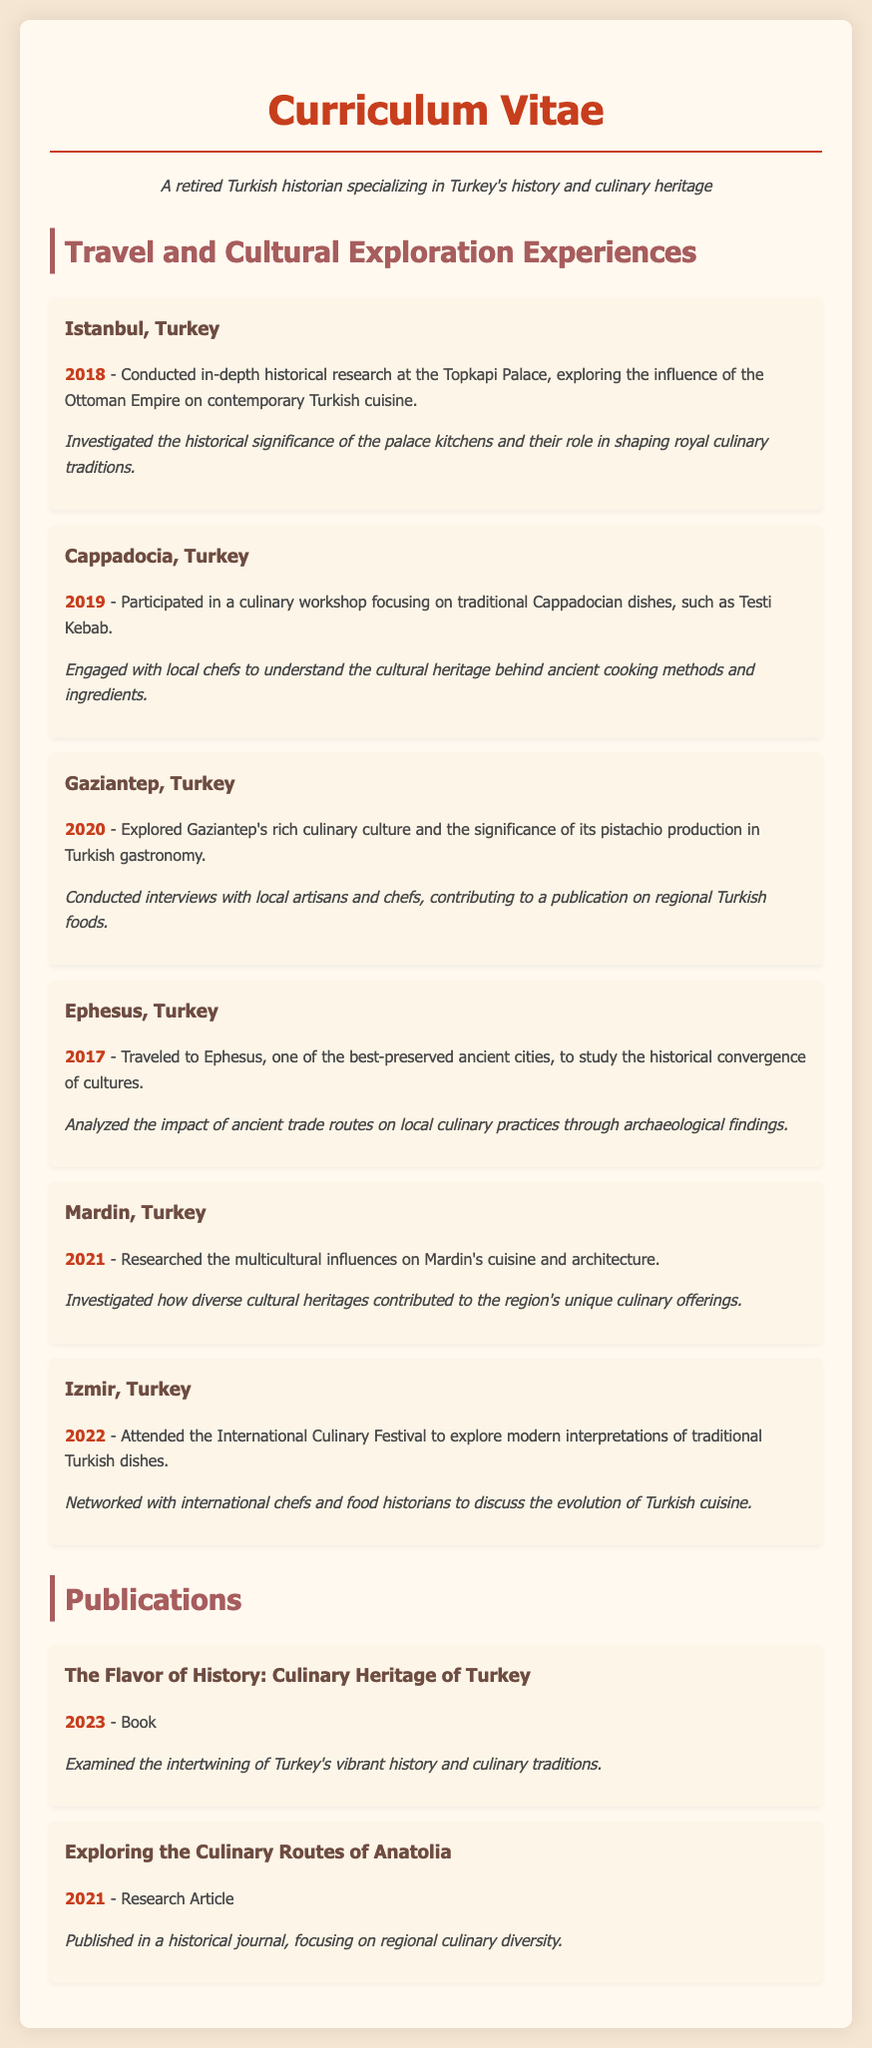What year did the research at Topkapi Palace take place? The document states that the in-depth historical research at Topkapi Palace was conducted in 2018.
Answer: 2018 What is the focus of the culinary workshop in Cappadocia? The workshop was centered around traditional Cappadocian dishes, specifically Testi Kebab.
Answer: Traditional Cappadocian dishes What region's culinary culture was explored in 2020? The document indicates that Gaziantep's culinary culture was the focus of exploration that year.
Answer: Gaziantep Which ancient city was visited in 2017 for research? Ephesus is the ancient city mentioned in the document as having been visited for study in 2017.
Answer: Ephesus What multicultural influences were researched in Mardin? The document highlights that the research focused on the influences on Mardin's cuisine and architecture.
Answer: Multicultural influences What type of event did the individual attend in Izmir in 2022? The document specifies that the individual attended the International Culinary Festival in Izmir.
Answer: International Culinary Festival What year was "The Flavor of History: Culinary Heritage of Turkey" published? The document states that this book was published in 2023.
Answer: 2023 What was the title of the research article published in 2021? The article published in 2021 is titled "Exploring the Culinary Routes of Anatolia."
Answer: Exploring the Culinary Routes of Anatolia How many culinary exploration experiences are listed in the document? The document lists a total of six travel and cultural exploration experiences.
Answer: Six 